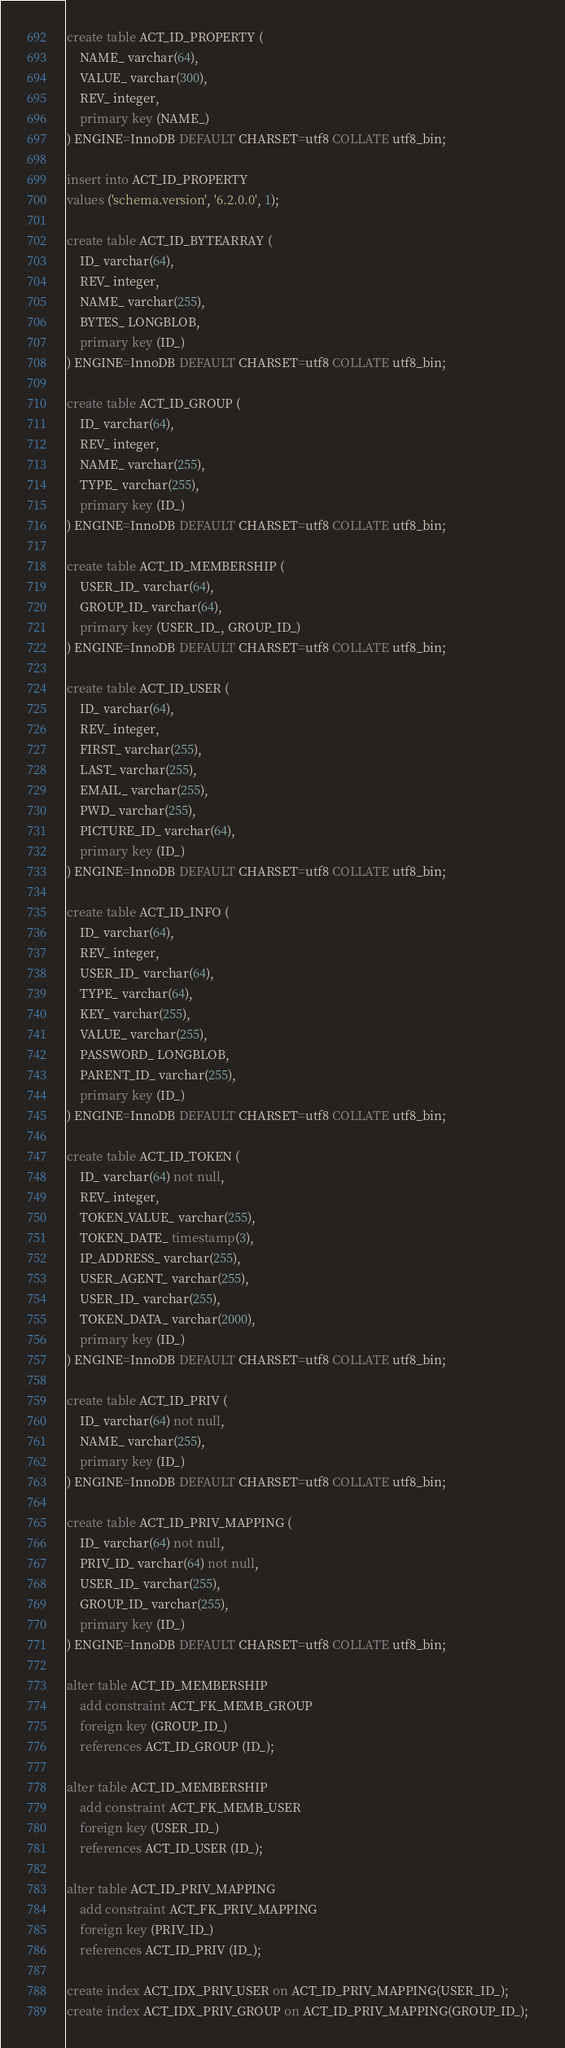<code> <loc_0><loc_0><loc_500><loc_500><_SQL_>create table ACT_ID_PROPERTY (
    NAME_ varchar(64),
    VALUE_ varchar(300),
    REV_ integer,
    primary key (NAME_)
) ENGINE=InnoDB DEFAULT CHARSET=utf8 COLLATE utf8_bin;

insert into ACT_ID_PROPERTY
values ('schema.version', '6.2.0.0', 1);

create table ACT_ID_BYTEARRAY (
    ID_ varchar(64),
    REV_ integer,
    NAME_ varchar(255),
    BYTES_ LONGBLOB,
    primary key (ID_)
) ENGINE=InnoDB DEFAULT CHARSET=utf8 COLLATE utf8_bin;

create table ACT_ID_GROUP (
    ID_ varchar(64),
    REV_ integer,
    NAME_ varchar(255),
    TYPE_ varchar(255),
    primary key (ID_)
) ENGINE=InnoDB DEFAULT CHARSET=utf8 COLLATE utf8_bin;

create table ACT_ID_MEMBERSHIP (
    USER_ID_ varchar(64),
    GROUP_ID_ varchar(64),
    primary key (USER_ID_, GROUP_ID_)
) ENGINE=InnoDB DEFAULT CHARSET=utf8 COLLATE utf8_bin;

create table ACT_ID_USER (
    ID_ varchar(64),
    REV_ integer,
    FIRST_ varchar(255),
    LAST_ varchar(255),
    EMAIL_ varchar(255),
    PWD_ varchar(255),
    PICTURE_ID_ varchar(64),
    primary key (ID_)
) ENGINE=InnoDB DEFAULT CHARSET=utf8 COLLATE utf8_bin;

create table ACT_ID_INFO (
    ID_ varchar(64),
    REV_ integer,
    USER_ID_ varchar(64),
    TYPE_ varchar(64),
    KEY_ varchar(255),
    VALUE_ varchar(255),
    PASSWORD_ LONGBLOB,
    PARENT_ID_ varchar(255),
    primary key (ID_)
) ENGINE=InnoDB DEFAULT CHARSET=utf8 COLLATE utf8_bin;

create table ACT_ID_TOKEN (
    ID_ varchar(64) not null,
    REV_ integer,
    TOKEN_VALUE_ varchar(255),
    TOKEN_DATE_ timestamp(3),
    IP_ADDRESS_ varchar(255),
    USER_AGENT_ varchar(255),
    USER_ID_ varchar(255),
    TOKEN_DATA_ varchar(2000),
    primary key (ID_)
) ENGINE=InnoDB DEFAULT CHARSET=utf8 COLLATE utf8_bin;

create table ACT_ID_PRIV (
    ID_ varchar(64) not null,
    NAME_ varchar(255),
    primary key (ID_)
) ENGINE=InnoDB DEFAULT CHARSET=utf8 COLLATE utf8_bin;

create table ACT_ID_PRIV_MAPPING (
    ID_ varchar(64) not null,
    PRIV_ID_ varchar(64) not null,
    USER_ID_ varchar(255),
    GROUP_ID_ varchar(255),
    primary key (ID_)
) ENGINE=InnoDB DEFAULT CHARSET=utf8 COLLATE utf8_bin;

alter table ACT_ID_MEMBERSHIP
    add constraint ACT_FK_MEMB_GROUP
    foreign key (GROUP_ID_)
    references ACT_ID_GROUP (ID_);
    
alter table ACT_ID_MEMBERSHIP
    add constraint ACT_FK_MEMB_USER
    foreign key (USER_ID_)
    references ACT_ID_USER (ID_);

alter table ACT_ID_PRIV_MAPPING 
    add constraint ACT_FK_PRIV_MAPPING 
    foreign key (PRIV_ID_) 
    references ACT_ID_PRIV (ID_);
    
create index ACT_IDX_PRIV_USER on ACT_ID_PRIV_MAPPING(USER_ID_);
create index ACT_IDX_PRIV_GROUP on ACT_ID_PRIV_MAPPING(GROUP_ID_);   
</code> 